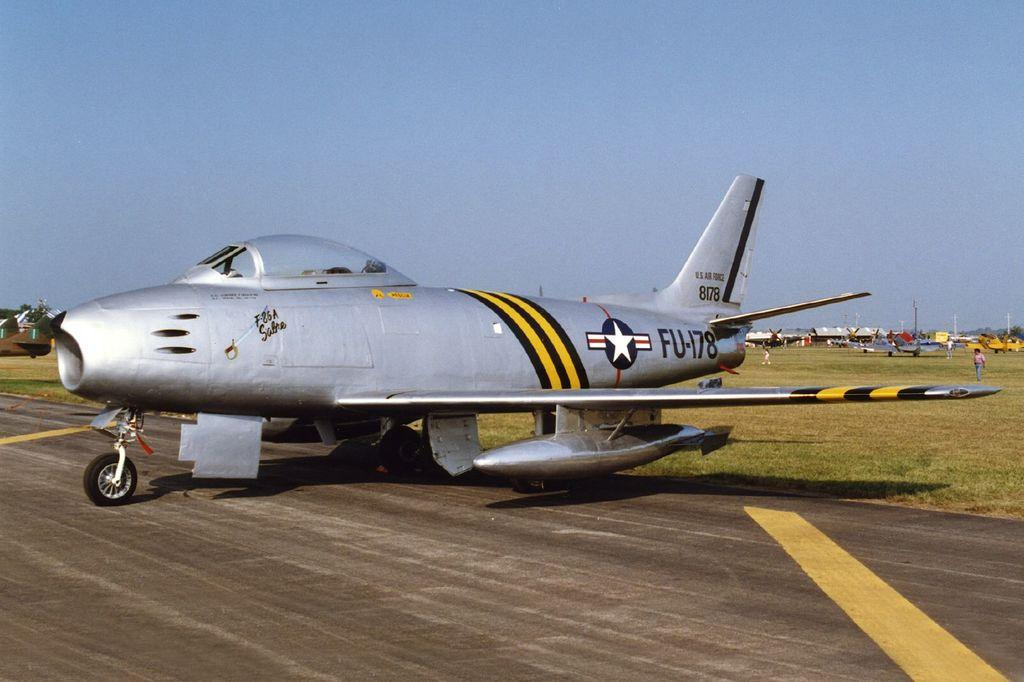<image>
Provide a brief description of the given image. A silver airplane with the call letters FU-178 and tail wing numbers 8178. 